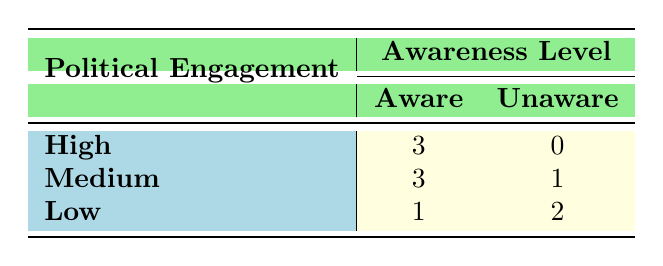What is the number of historical sites where political engagement is high and awareness is aware? From the table, we can see that there are three entries under the "High" political engagement that correspond to "Aware". These are Ormskirk Parish Church, Little Marton Windmill, and Blackburne House.
Answer: 3 How many historical sites have a medium political engagement and are unaware of their awareness level? The table lists under "Medium" political engagement that corresponds to "Unaware" as one entry, which is St. Cuthbert's Church.
Answer: 1 Is there any historical site with low political engagement that is also aware? By examining the table, there is one entry under "Low" political engagement that corresponds to "Aware", which is The Coach House. Therefore, the answer is yes.
Answer: Yes What is the total number of historical sites listed in the table? The table lists a total of ten historical sites. This is simply counted from the entries present in the table.
Answer: 10 What is the difference in the number of historical sites that are aware between high and low political engagement? High political engagement has 3 sites that are "Aware" while low political engagement has only 1 site. The difference is calculated as 3 - 1 = 2.
Answer: 2 How many historical sites are there with high political engagement that are unaware? The table indicates that there are no entries under "High" political engagement corresponding to "Unaware". Thus, the count is zero.
Answer: 0 What fraction of the historical sites listed are aware, given that the total number of aware sites is counted under all political engagement levels? There are 3 aware sites under high, 3 under medium, and 1 under low engagement, totaling 7 aware sites. The fraction is 7 out of 10, which simplifies to 7/10.
Answer: 7/10 What is the highest awareness level recorded for the medium political engagement category? From the table, the medium political engagement category has both "Aware" (3 sites) and "Unaware" (1 site) entries. The highest awareness level in this category is clearly "Aware".
Answer: Aware Which political engagement level has the highest number of historical sites? Analyzing the table, the medium political engagement level has a total of 4 sites (3 aware and 1 unaware), compared to 3 sites for high and 3 for low. Therefore, medium has the highest count.
Answer: Medium 